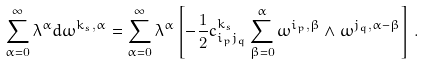<formula> <loc_0><loc_0><loc_500><loc_500>\sum _ { \alpha = 0 } ^ { \infty } \lambda ^ { \alpha } d \omega ^ { k _ { s } , \alpha } = \sum _ { \alpha = 0 } ^ { \infty } \lambda ^ { \alpha } \left [ - \frac { 1 } { 2 } c _ { i _ { p } j _ { q } } ^ { k _ { s } } \sum _ { \beta = 0 } ^ { \alpha } \omega ^ { i _ { p } , \beta } \wedge \omega ^ { j _ { q } , \alpha - \beta } \right ] \, .</formula> 